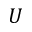<formula> <loc_0><loc_0><loc_500><loc_500>U</formula> 